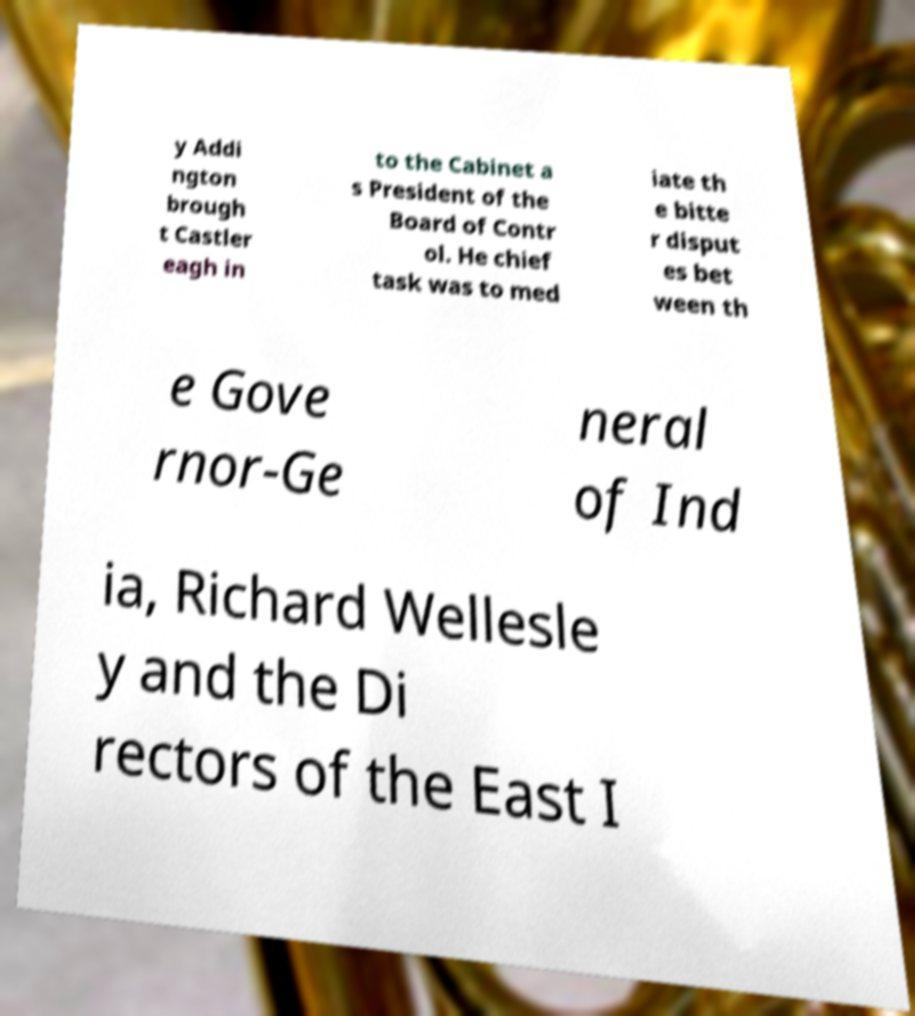There's text embedded in this image that I need extracted. Can you transcribe it verbatim? y Addi ngton brough t Castler eagh in to the Cabinet a s President of the Board of Contr ol. He chief task was to med iate th e bitte r disput es bet ween th e Gove rnor-Ge neral of Ind ia, Richard Wellesle y and the Di rectors of the East I 